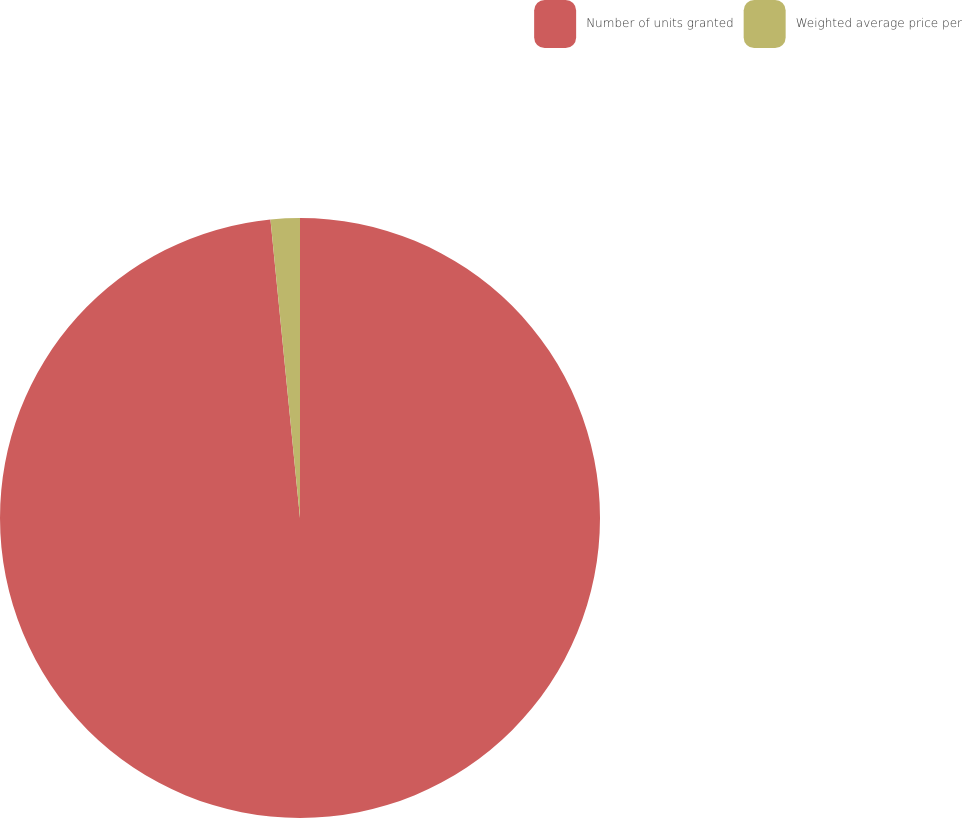Convert chart to OTSL. <chart><loc_0><loc_0><loc_500><loc_500><pie_chart><fcel>Number of units granted<fcel>Weighted average price per<nl><fcel>98.43%<fcel>1.57%<nl></chart> 